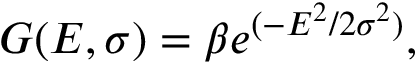<formula> <loc_0><loc_0><loc_500><loc_500>G ( E , \sigma ) = \beta e ^ { ( - E ^ { 2 } / 2 \sigma ^ { 2 } ) } ,</formula> 